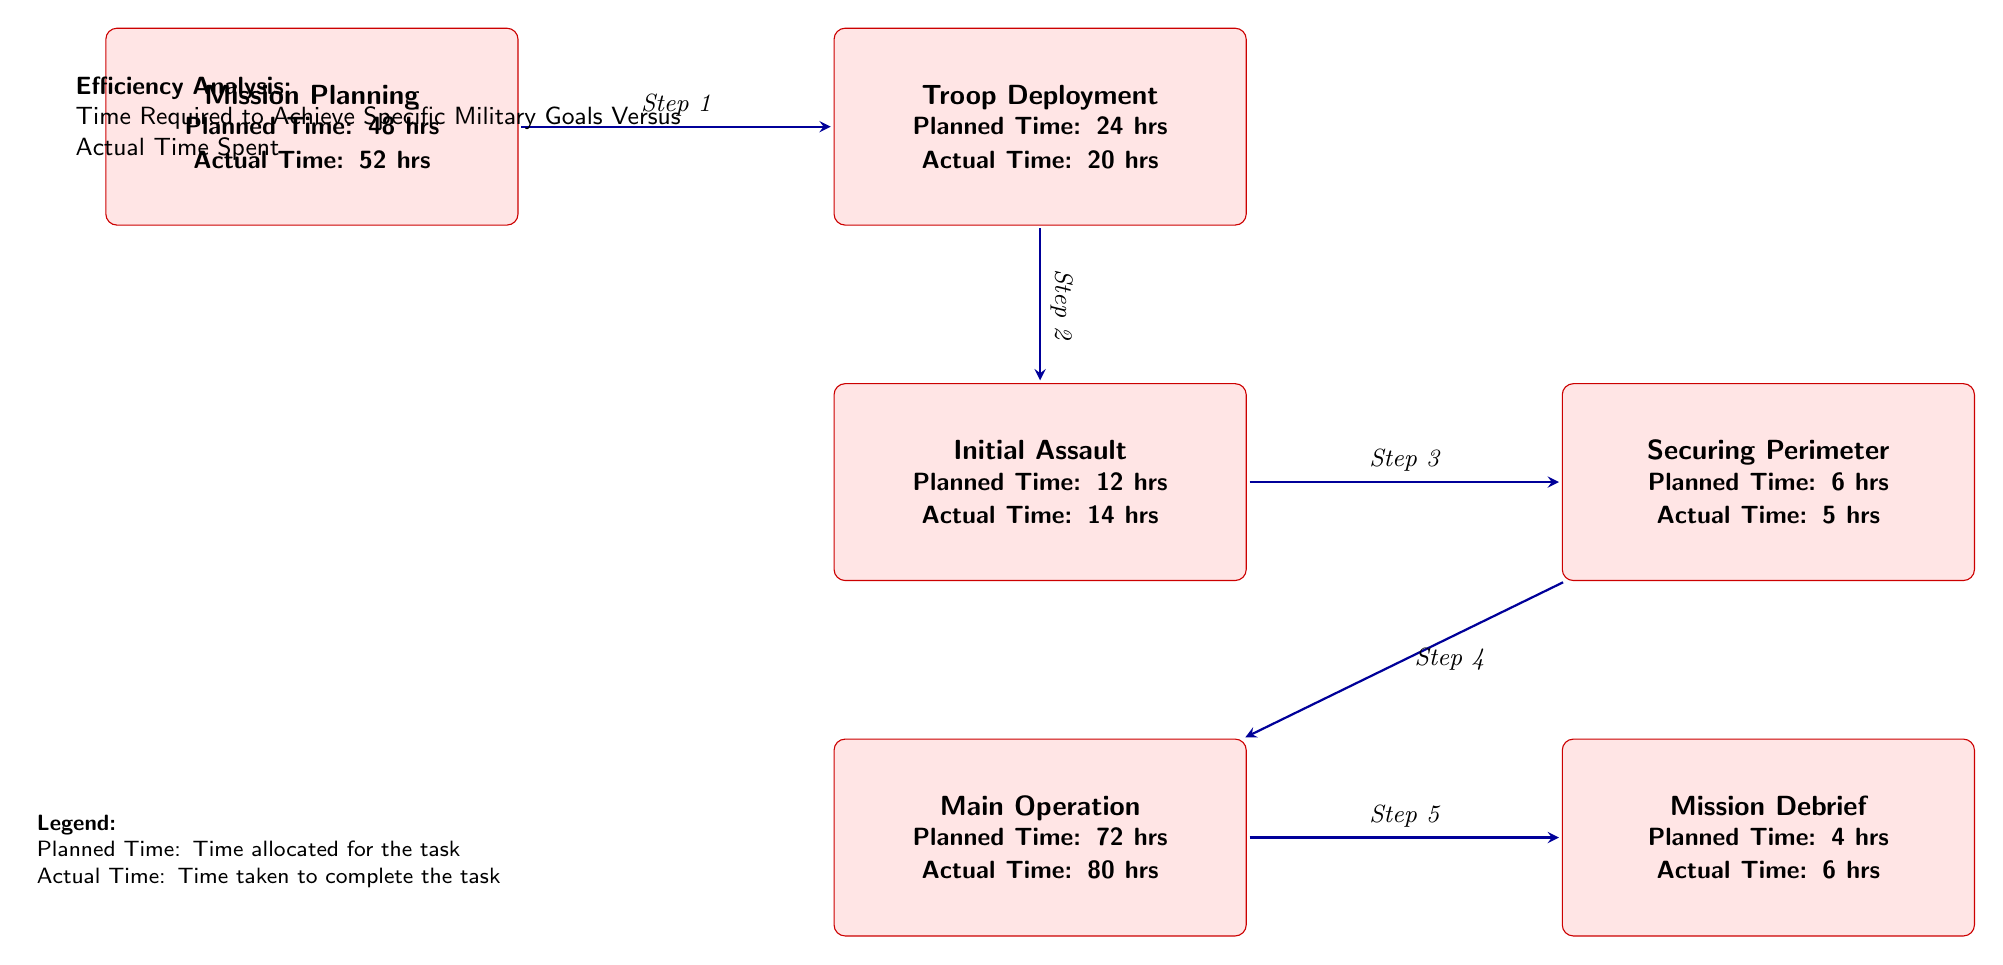What is the planned time for Mission Planning? The planned time for Mission Planning is listed within the box labeled 'Mission Planning'. It clearly states "Planned Time: 48 hrs".
Answer: 48 hrs How much actual time was spent on Securing Perimeter? In the box labeled 'Securing Perimeter', it states "Actual Time: 5 hrs". Thus, the actual time spent is directly taken from that text.
Answer: 5 hrs What task has the highest planned time? By examining each task's planned time in the diagram, 'Main Operation' has the highest planned time at "72 hrs".
Answer: Main Operation How many steps are there in the mission flow? The flow is depicted by the arrows between the boxes, showing a sequence of tasks. Counted carefully, there are 5 arrows indicating 5 steps in total.
Answer: 5 Which task had a delay compared to its planned time? Looking at the nodes, both 'Mission Planning' and 'Initial Assault' exceeded their planned times. However, 'Mission Planning' has the most considerable discrepancy with "Planned Time: 48 hrs" versus "Actual Time: 52 hrs".
Answer: Mission Planning What is the total actual time for all tasks combined? The total actual time can be calculated by adding each task's actual time: 52 + 20 + 14 + 5 + 80 + 6 = 177 hrs.
Answer: 177 hrs Which task experienced the least time spent compared to its planned time? The task 'Securing Perimeter' shows a planned time of "6 hrs" and an actual time of "5 hrs", representing the smallest difference between planned and actual times.
Answer: Securing Perimeter What is the purpose of the legend in this diagram? The legend serves to clarify the definitions of "Planned Time" and "Actual Time" for the reader, enhancing understanding of the diagram's content.
Answer: Clarification of terms How many tasks exceeded their planned time? Examining the actual times relative to the planned times reveals that three tasks - 'Mission Planning', 'Initial Assault', and 'Main Operation' - exceeded their planned time.
Answer: 3 